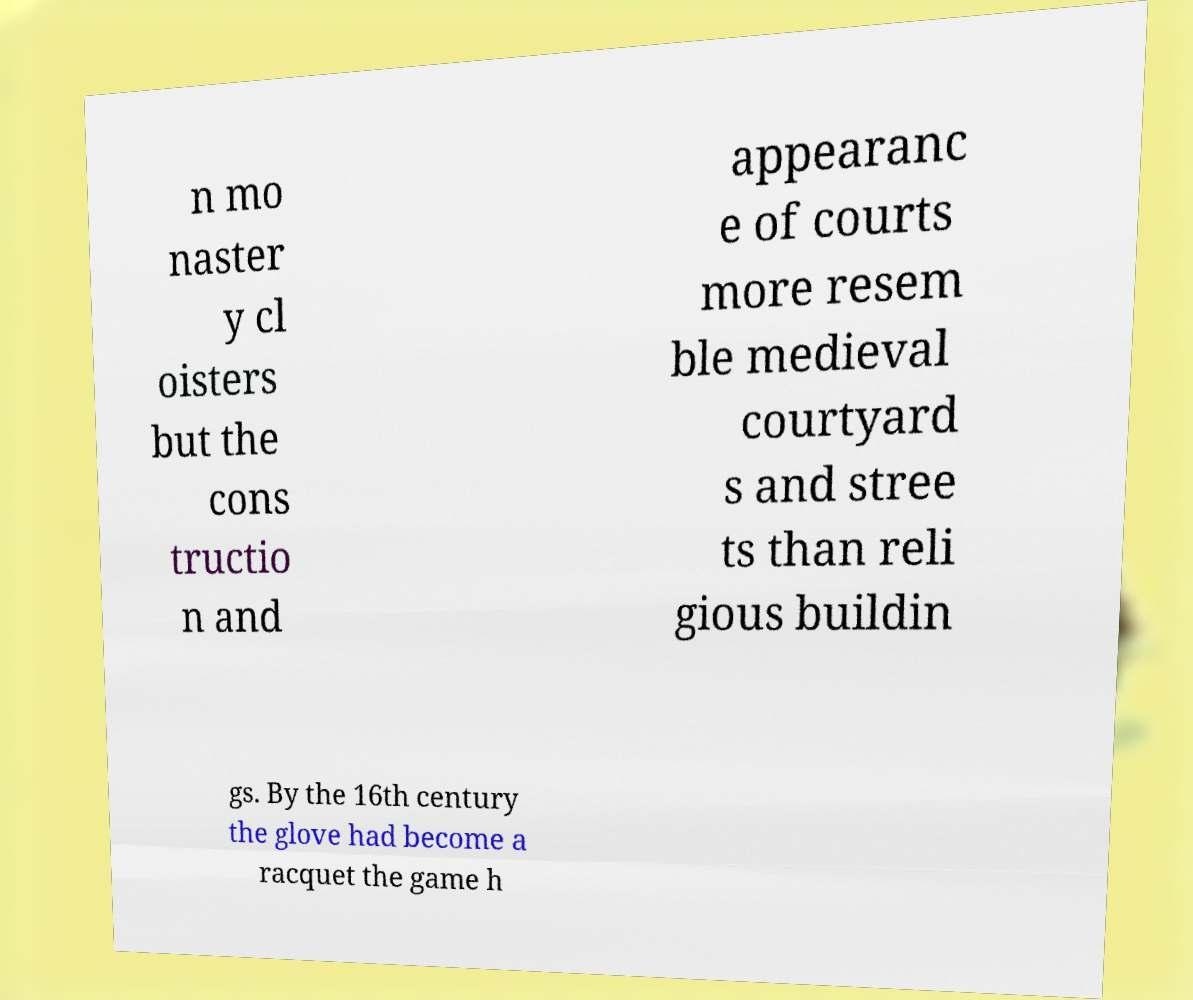Could you assist in decoding the text presented in this image and type it out clearly? n mo naster y cl oisters but the cons tructio n and appearanc e of courts more resem ble medieval courtyard s and stree ts than reli gious buildin gs. By the 16th century the glove had become a racquet the game h 